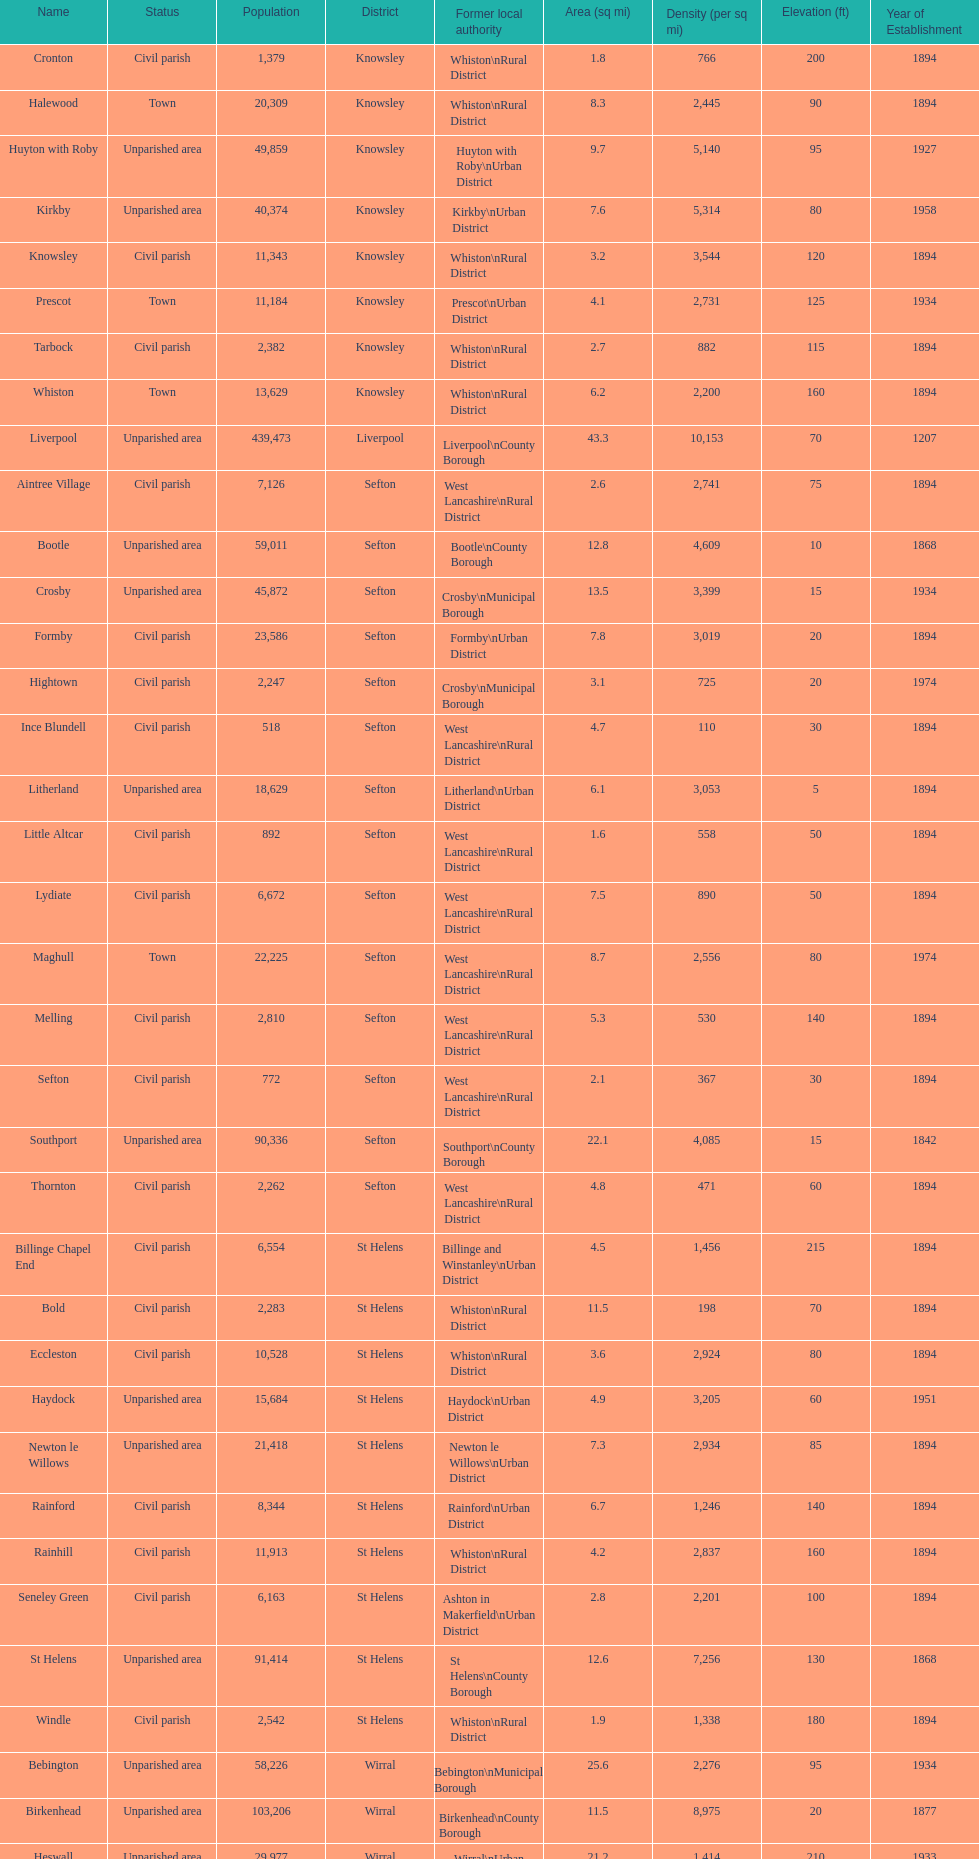How many people live in the bold civil parish? 2,283. 